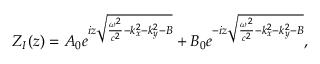<formula> <loc_0><loc_0><loc_500><loc_500>Z _ { I } ( z ) = A _ { 0 } e ^ { i z \sqrt { \frac { \omega ^ { 2 } } { c ^ { 2 } } - k _ { x } ^ { 2 } - k _ { y } ^ { 2 } - B } } + B _ { 0 } e ^ { - i z \sqrt { \frac { \omega ^ { 2 } } { c ^ { 2 } } - k _ { x } ^ { 2 } - k _ { y } ^ { 2 } - B } } ,</formula> 